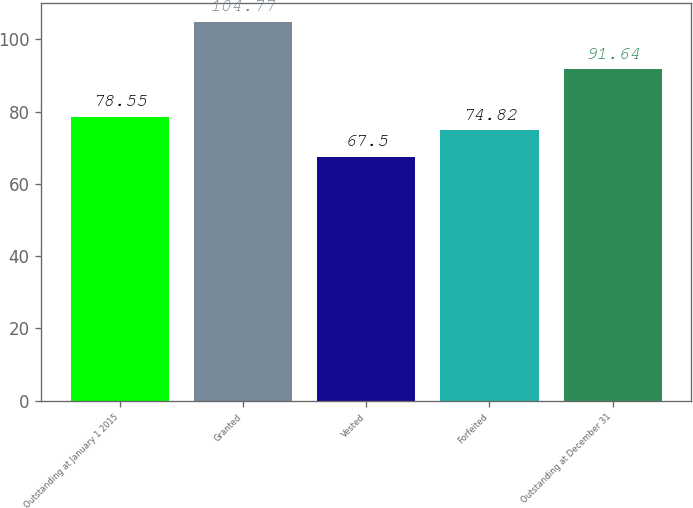<chart> <loc_0><loc_0><loc_500><loc_500><bar_chart><fcel>Outstanding at January 1 2015<fcel>Granted<fcel>Vested<fcel>Forfeited<fcel>Outstanding at December 31<nl><fcel>78.55<fcel>104.77<fcel>67.5<fcel>74.82<fcel>91.64<nl></chart> 